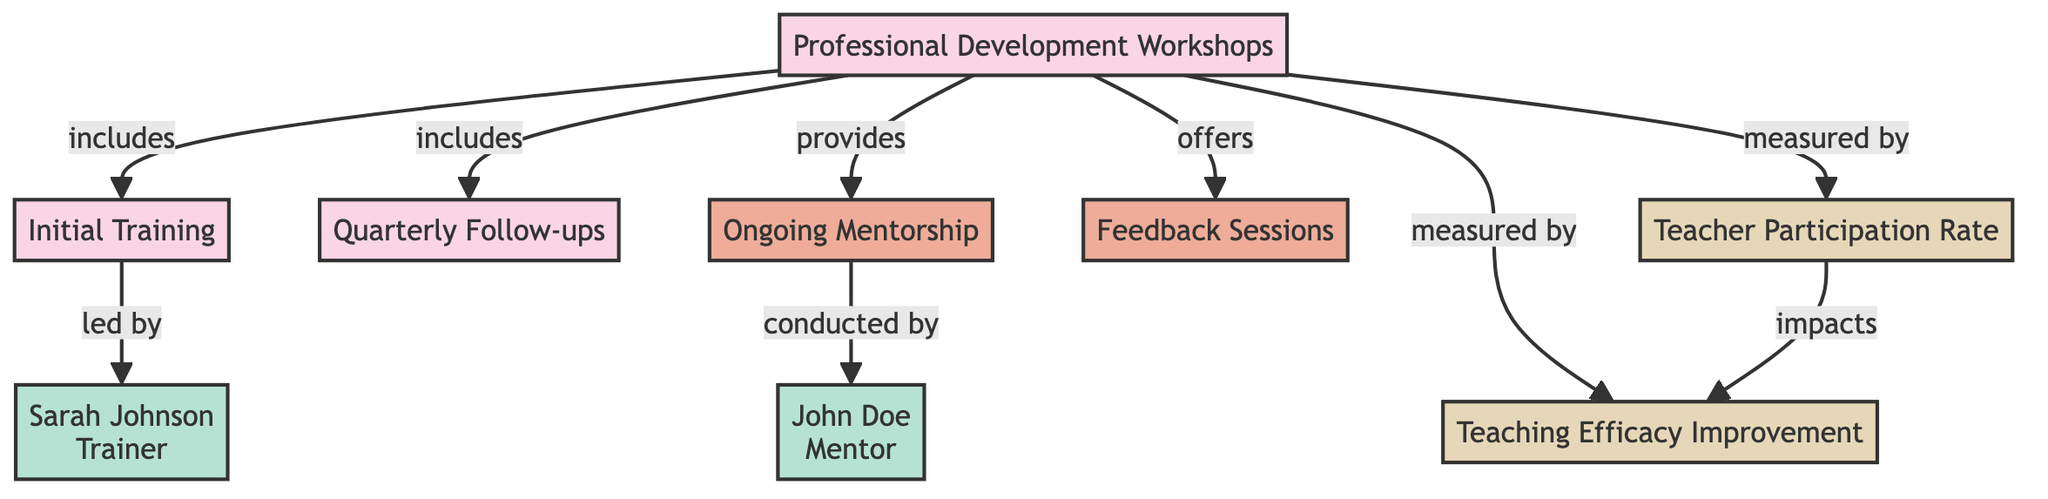What types of professional development workshops are included? The diagram specifies that the professional development workshops include initial training and quarterly follow-ups. It indicates these through directed relationships from the workshops node.
Answer: Initial training and quarterly follow-ups Who leads the initial training? The diagram indicates that Sarah Johnson is the trainer who leads the initial training session, connecting the initial training node directly to her node.
Answer: Sarah Johnson What is measured by the teacher participation rate? The diagram shows that the teacher participation rate is a metric that arises from the professional development workshops node, indicating it measures participation related to these workshops.
Answer: Participation in professional development workshops Which process is conducted by John Doe? The ongoing mentorship is shown in the diagram to be conducted by John Doe, connecting the ongoing mentorship node to his node.
Answer: Ongoing mentorship What impacts the teaching efficacy improvement? The diagram illustrates that the teacher participation rate impacts the teaching efficacy improvement, which connects these two metrics through the directed edge pointing from the participation rate to the teaching efficacy improvement.
Answer: Teacher participation rate What are the two main outcomes measured in this diagram? The diagram visually outlines two outcomes: teacher participation rate and teaching efficacy improvement, which are both categorized under metrics.
Answer: Teacher Participation Rate and Teaching Efficacy Improvement How many events are shown in the diagram? In the diagram, four events are identified: professional development workshops, initial training, quarterly follow-ups, and feedback sessions. By counting the distinct event nodes, we determine the total.
Answer: Four What does ongoing mentorship relate to in this diagram? The ongoing mentorship connects to the professional development workshops node, indicating that it is part of the overall framework for teacher professional development.
Answer: Professional Development Workshops What is the relationship between participation rates and teaching efficacy improvement? The diagram indicates a direct influence whereby the teacher participation rate impacts the teaching efficacy improvement, establishing a cause-and-effect relationship between these two metrics.
Answer: Teacher participation rate impacts teaching efficacy improvement 